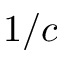<formula> <loc_0><loc_0><loc_500><loc_500>1 / c</formula> 